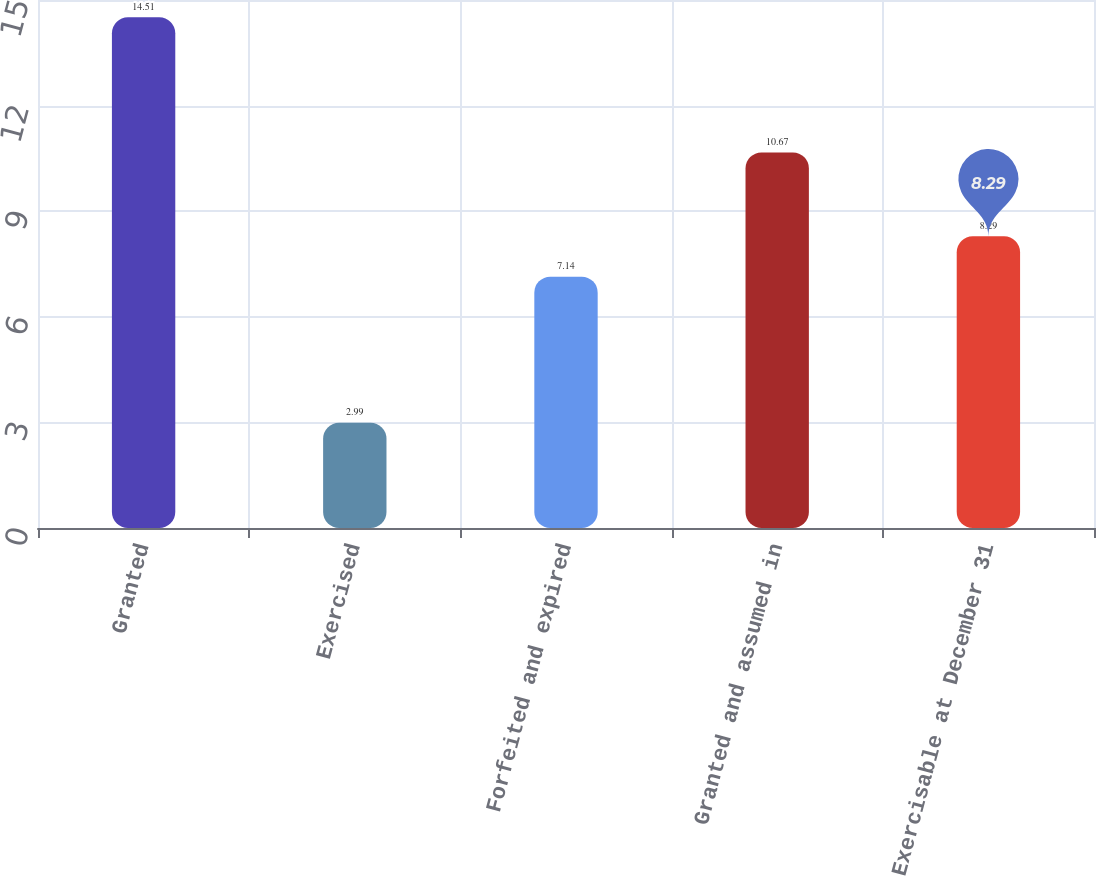Convert chart. <chart><loc_0><loc_0><loc_500><loc_500><bar_chart><fcel>Granted<fcel>Exercised<fcel>Forfeited and expired<fcel>Granted and assumed in<fcel>Exercisable at December 31<nl><fcel>14.51<fcel>2.99<fcel>7.14<fcel>10.67<fcel>8.29<nl></chart> 